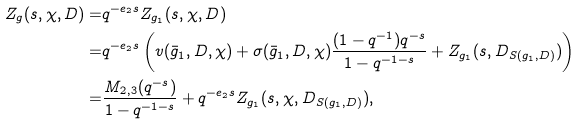Convert formula to latex. <formula><loc_0><loc_0><loc_500><loc_500>Z _ { g } ( s , \chi , D ) = & q ^ { - e _ { 2 } s } Z _ { g _ { 1 } } ( s , \chi , D ) \\ = & q ^ { - e _ { 2 } s } \left ( v ( \bar { g } _ { 1 } , D , \chi ) + \sigma ( \bar { g } _ { 1 } , D , \chi ) \frac { ( 1 - q ^ { - 1 } ) q ^ { - s } } { 1 - q ^ { - 1 - s } } + Z _ { g _ { 1 } } ( s , D _ { S ( g _ { 1 } , D ) } ) \right ) \\ = & \frac { M _ { 2 , 3 } ( q ^ { - s } ) } { 1 - q ^ { - 1 - s } } + q ^ { - e _ { 2 } s } Z _ { g _ { 1 } } ( s , \chi , D _ { S ( g _ { 1 } , D ) } ) ,</formula> 